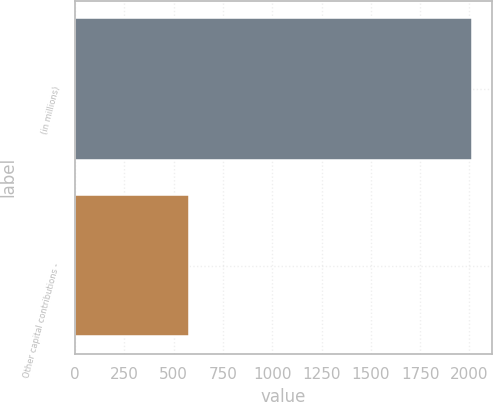Convert chart. <chart><loc_0><loc_0><loc_500><loc_500><bar_chart><fcel>(in millions)<fcel>Other capital contributions -<nl><fcel>2012<fcel>579<nl></chart> 